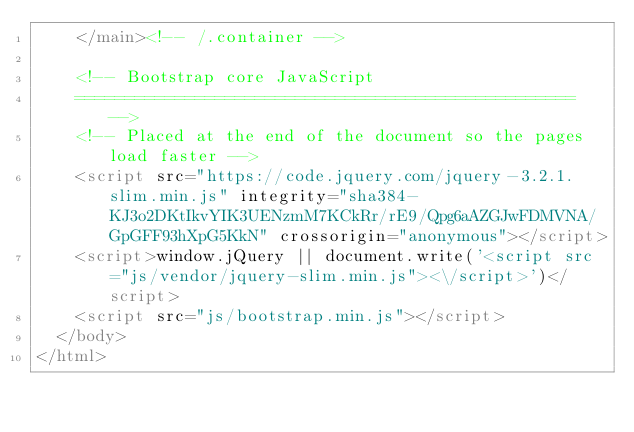<code> <loc_0><loc_0><loc_500><loc_500><_HTML_>    </main><!-- /.container -->

    <!-- Bootstrap core JavaScript
    ================================================== -->
    <!-- Placed at the end of the document so the pages load faster -->
    <script src="https://code.jquery.com/jquery-3.2.1.slim.min.js" integrity="sha384-KJ3o2DKtIkvYIK3UENzmM7KCkRr/rE9/Qpg6aAZGJwFDMVNA/GpGFF93hXpG5KkN" crossorigin="anonymous"></script>
    <script>window.jQuery || document.write('<script src="js/vendor/jquery-slim.min.js"><\/script>')</script>
    <script src="js/bootstrap.min.js"></script>
  </body>
</html>
</code> 